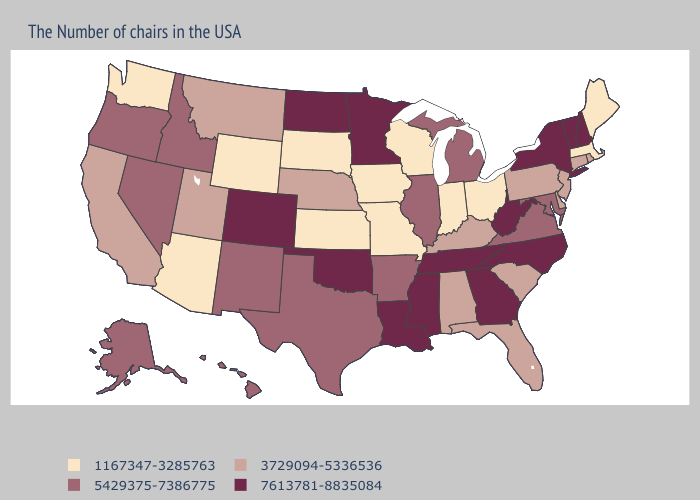Which states have the highest value in the USA?
Concise answer only. New Hampshire, Vermont, New York, North Carolina, West Virginia, Georgia, Tennessee, Mississippi, Louisiana, Minnesota, Oklahoma, North Dakota, Colorado. What is the highest value in the Northeast ?
Write a very short answer. 7613781-8835084. What is the highest value in the MidWest ?
Write a very short answer. 7613781-8835084. What is the lowest value in the USA?
Concise answer only. 1167347-3285763. Which states have the highest value in the USA?
Give a very brief answer. New Hampshire, Vermont, New York, North Carolina, West Virginia, Georgia, Tennessee, Mississippi, Louisiana, Minnesota, Oklahoma, North Dakota, Colorado. Name the states that have a value in the range 7613781-8835084?
Keep it brief. New Hampshire, Vermont, New York, North Carolina, West Virginia, Georgia, Tennessee, Mississippi, Louisiana, Minnesota, Oklahoma, North Dakota, Colorado. Name the states that have a value in the range 5429375-7386775?
Answer briefly. Maryland, Virginia, Michigan, Illinois, Arkansas, Texas, New Mexico, Idaho, Nevada, Oregon, Alaska, Hawaii. Name the states that have a value in the range 7613781-8835084?
Give a very brief answer. New Hampshire, Vermont, New York, North Carolina, West Virginia, Georgia, Tennessee, Mississippi, Louisiana, Minnesota, Oklahoma, North Dakota, Colorado. Name the states that have a value in the range 1167347-3285763?
Concise answer only. Maine, Massachusetts, Ohio, Indiana, Wisconsin, Missouri, Iowa, Kansas, South Dakota, Wyoming, Arizona, Washington. What is the value of Kansas?
Concise answer only. 1167347-3285763. Does Colorado have the highest value in the West?
Quick response, please. Yes. Among the states that border Georgia , which have the lowest value?
Write a very short answer. South Carolina, Florida, Alabama. What is the value of Arkansas?
Be succinct. 5429375-7386775. Does New Hampshire have the same value as Michigan?
Short answer required. No. Does Colorado have the lowest value in the West?
Answer briefly. No. 